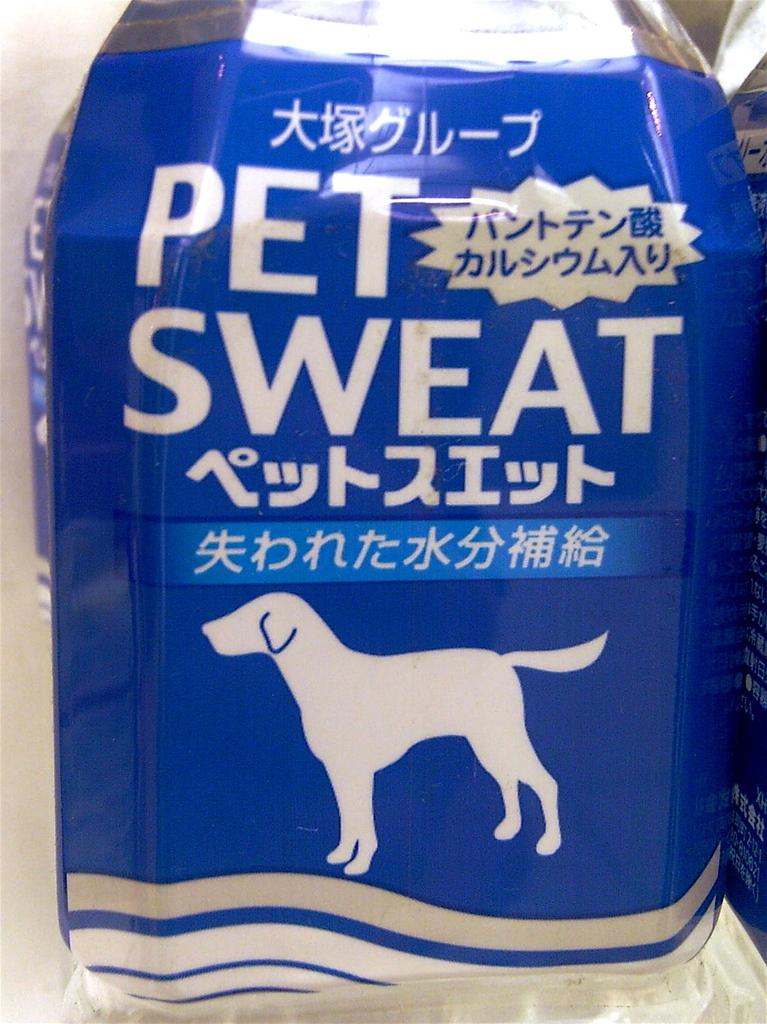What is the main object in the image? There is a container in the image. What can be seen on the container? The container has text on it. Where is the container located? The container is placed on a surface. How many rabbits are hopping on the side of the container in the image? There are no rabbits present in the image, and the container does not have a side with rabbits hopping on it. 